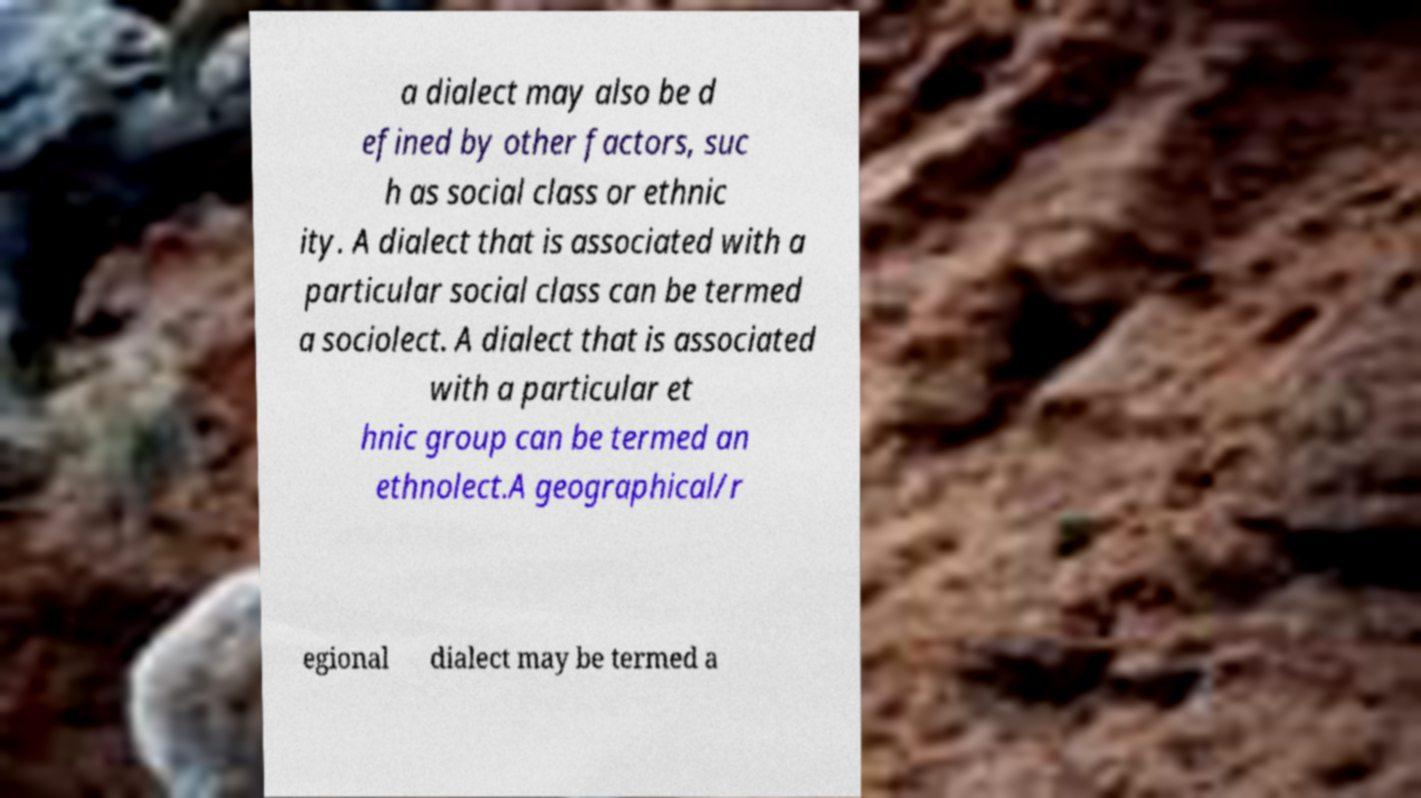What messages or text are displayed in this image? I need them in a readable, typed format. a dialect may also be d efined by other factors, suc h as social class or ethnic ity. A dialect that is associated with a particular social class can be termed a sociolect. A dialect that is associated with a particular et hnic group can be termed an ethnolect.A geographical/r egional dialect may be termed a 